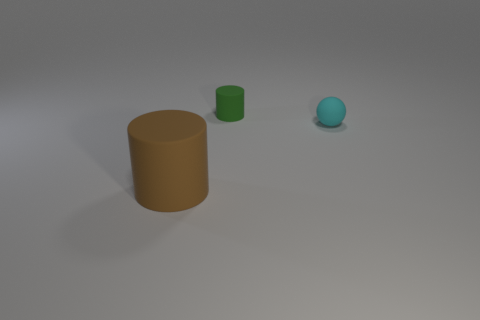Add 2 cubes. How many objects exist? 5 Subtract all cylinders. How many objects are left? 1 Subtract all tiny cyan matte spheres. Subtract all cyan metallic cylinders. How many objects are left? 2 Add 2 large brown cylinders. How many large brown cylinders are left? 3 Add 1 tiny green metallic cubes. How many tiny green metallic cubes exist? 1 Subtract 0 purple spheres. How many objects are left? 3 